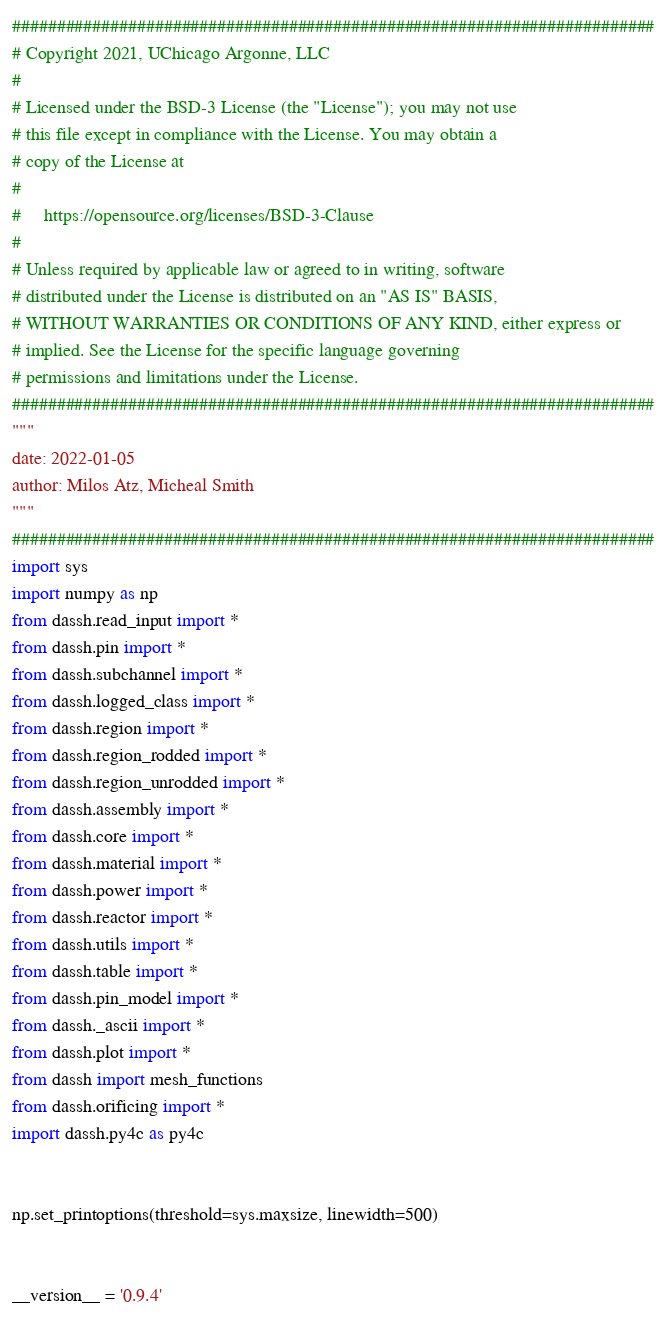<code> <loc_0><loc_0><loc_500><loc_500><_Python_>########################################################################
# Copyright 2021, UChicago Argonne, LLC
#
# Licensed under the BSD-3 License (the "License"); you may not use
# this file except in compliance with the License. You may obtain a
# copy of the License at
#
#     https://opensource.org/licenses/BSD-3-Clause
#
# Unless required by applicable law or agreed to in writing, software
# distributed under the License is distributed on an "AS IS" BASIS,
# WITHOUT WARRANTIES OR CONDITIONS OF ANY KIND, either express or
# implied. See the License for the specific language governing
# permissions and limitations under the License.
########################################################################
"""
date: 2022-01-05
author: Milos Atz, Micheal Smith
"""
########################################################################
import sys
import numpy as np
from dassh.read_input import *
from dassh.pin import *
from dassh.subchannel import *
from dassh.logged_class import *
from dassh.region import *
from dassh.region_rodded import *
from dassh.region_unrodded import *
from dassh.assembly import *
from dassh.core import *
from dassh.material import *
from dassh.power import *
from dassh.reactor import *
from dassh.utils import *
from dassh.table import *
from dassh.pin_model import *
from dassh._ascii import *
from dassh.plot import *
from dassh import mesh_functions
from dassh.orificing import *
import dassh.py4c as py4c


np.set_printoptions(threshold=sys.maxsize, linewidth=500)


__version__ = '0.9.4'
</code> 